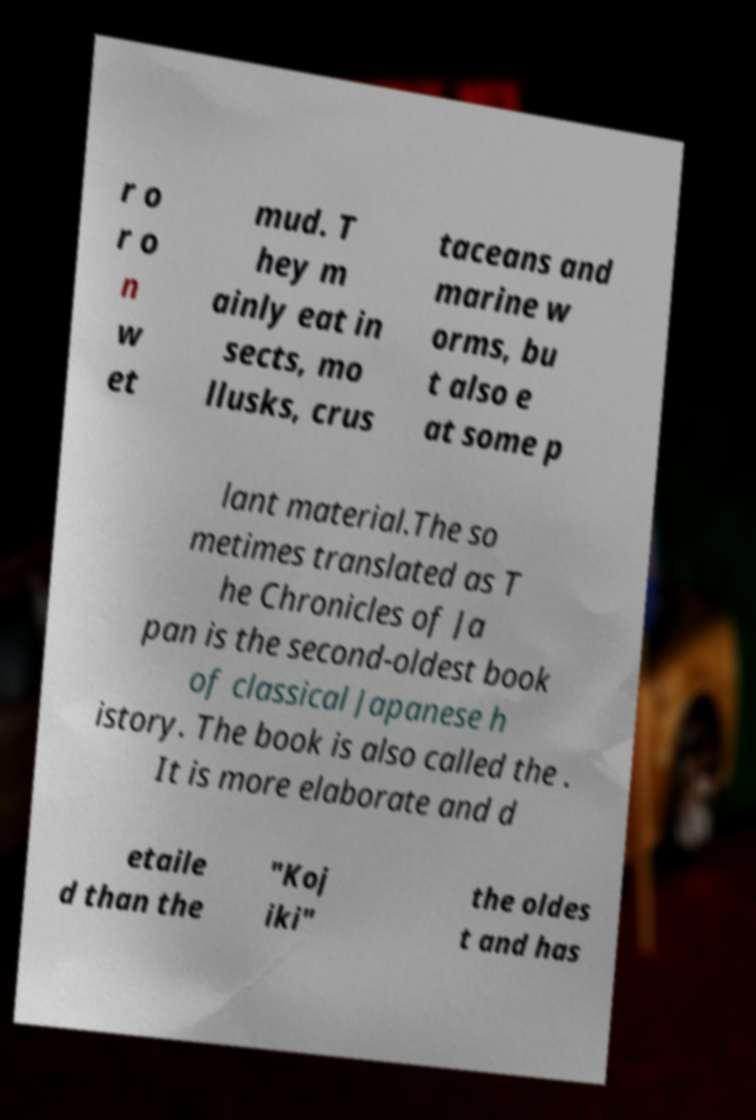Can you accurately transcribe the text from the provided image for me? r o r o n w et mud. T hey m ainly eat in sects, mo llusks, crus taceans and marine w orms, bu t also e at some p lant material.The so metimes translated as T he Chronicles of Ja pan is the second-oldest book of classical Japanese h istory. The book is also called the . It is more elaborate and d etaile d than the "Koj iki" the oldes t and has 